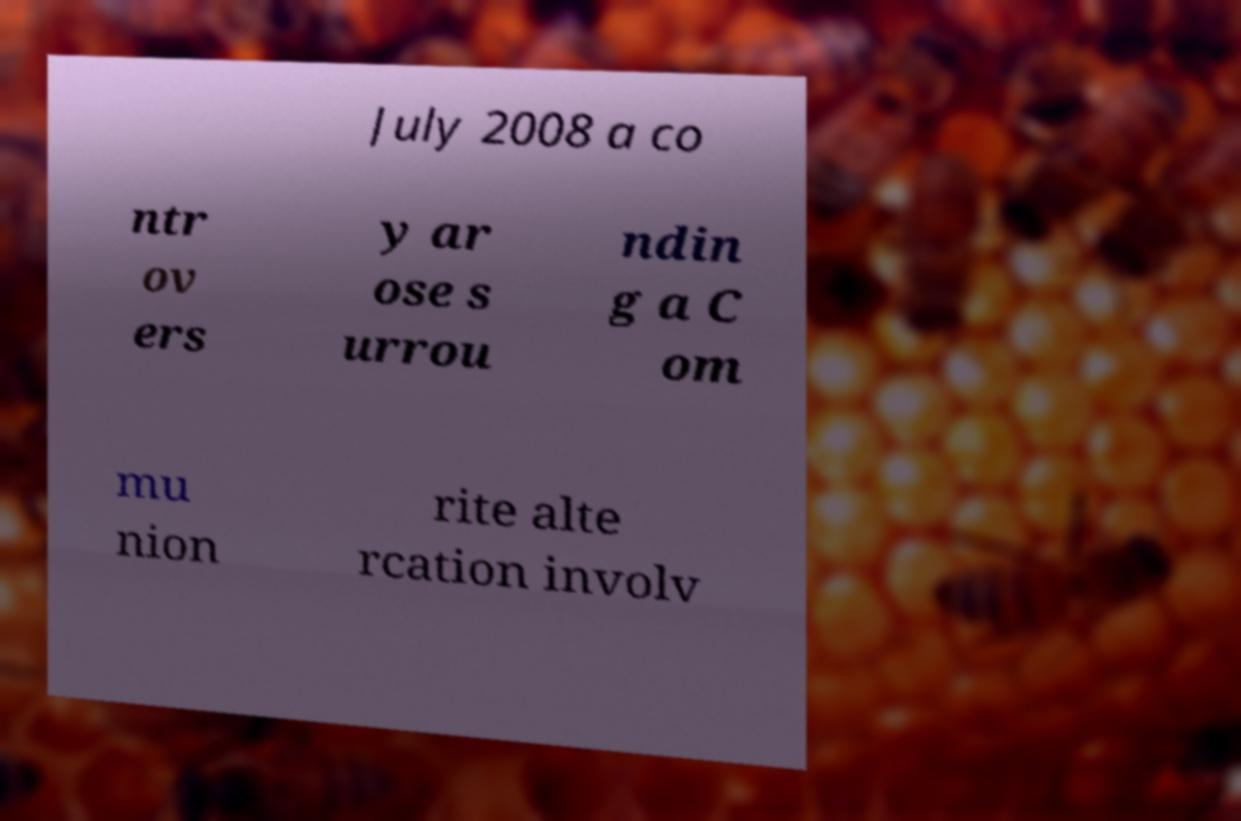Please read and relay the text visible in this image. What does it say? July 2008 a co ntr ov ers y ar ose s urrou ndin g a C om mu nion rite alte rcation involv 